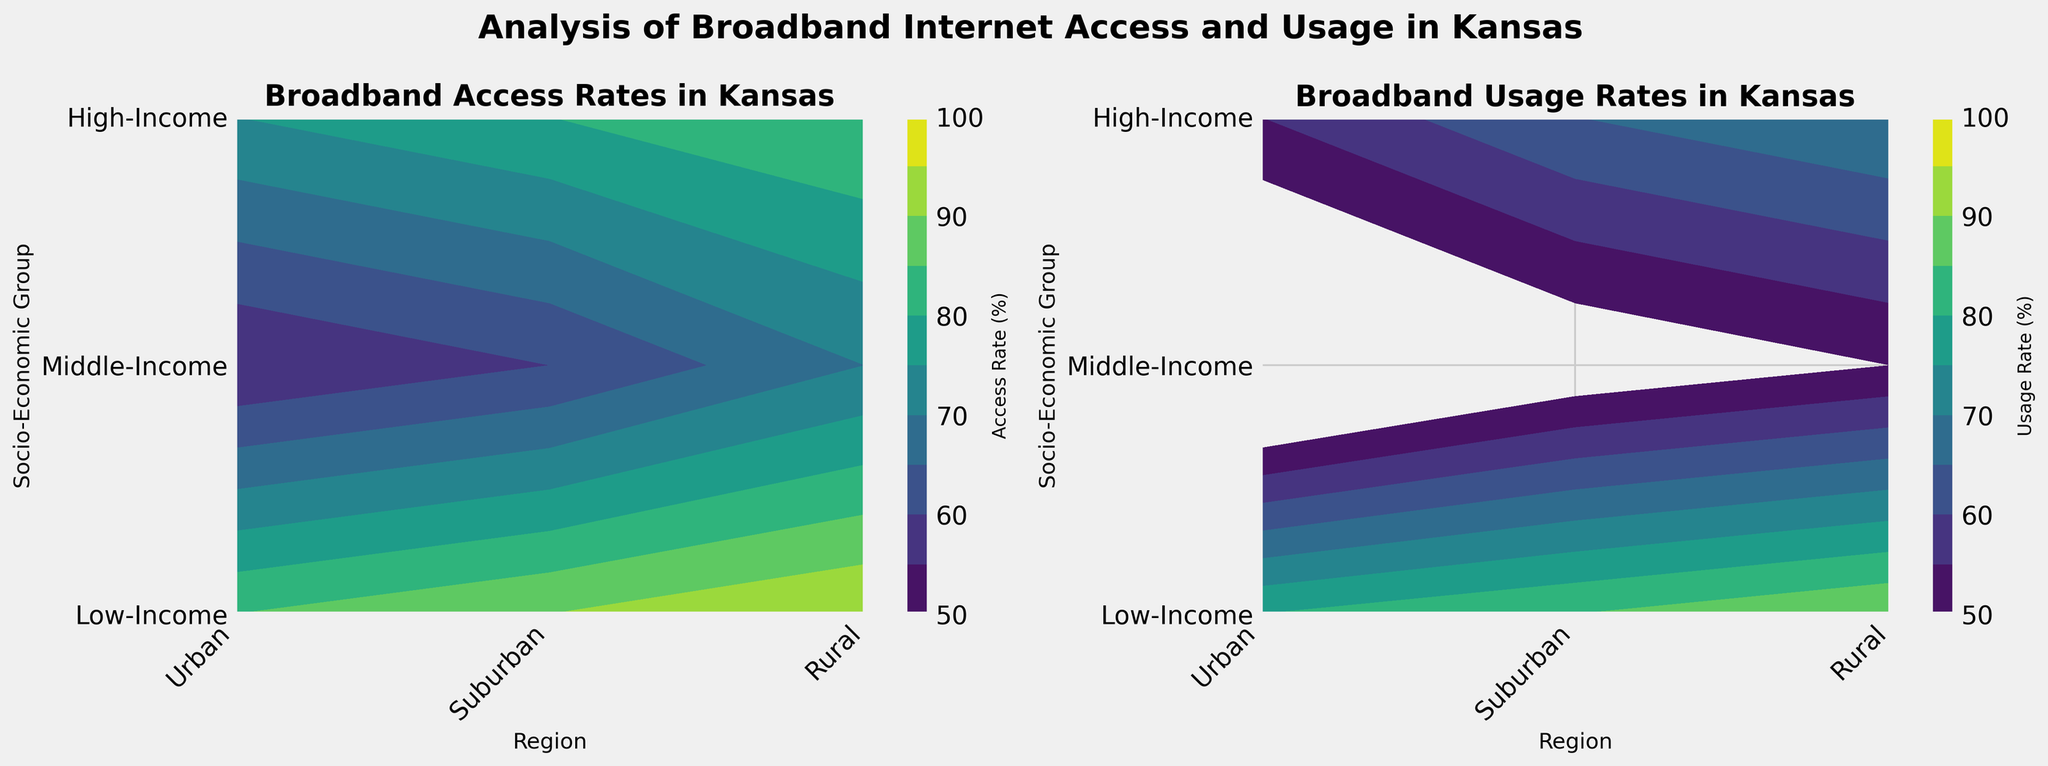What is the highest broadband access rate among all socio-economic groups and regions? To find the highest broadband access rate, look at the color gradients on the "Broadband Access Rates in Kansas" contour plot. The darkest color will represent the highest rate. Cross-reference this color with the socio-economic group and region.
Answer: 95% Which socio-economic group has the lowest broadband usage rate in rural areas? Examine the "Broadband Usage Rates in Kansas" contour plot, focusing on the rural areas (last column). Identify the socio-economic group corresponding to the lightest color (indicating the lowest value).
Answer: Low-Income How does the broadband usage rate in suburban areas for middle-income groups compare to low-income groups? Look at the "Broadband Usage Rates in Kansas" contour plot. Compare the shades of color in the suburban region (middle column) for both the middle-income and low-income groups (y-axis labels). Middle-income has a darker shade compared to low-income, indicating a higher usage rate.
Answer: Higher What is the average broadband access rate for the high-income group across all regions? Identify the access rates for the high-income group in urban, suburban, and rural regions: 95% (Urban), 90% (Suburban), and 85% (Rural). Add these rates and divide by the number of regions (3). (95 + 90 + 85) / 3 = 270 / 3.
Answer: 90% Which region experiences the most significant difference between broadband access and usage rates for middle-income groups? Find the difference between broadband access and usage rates for middle-income groups in each region: Urban (85 - 70), Suburban (80 - 65), Rural (75 - 55). Compare these differences. Urban: 15, Suburban: 15, Rural: 20. The rural region has the most significant difference.
Answer: Rural Is the broadband access rate generally higher or lower than the usage rate for all socio-economic groups? Compare color gradients in both plots. Generally, the access rates (contour plot to the left) have darker shades compared to the usage rates (contour plot to the right), indicating higher access rates relative to usage rates.
Answer: Higher What's the range of broadband usage rates for the low-income group across all regions? Look at the "Broadband Usage Rates in Kansas" contour plot. Identify the usage rates for the low-income group across Urban, Suburban, and Rural regions: 50%, 45%, and 35% respectively. The range is calculated by subtracting the minimum value from the maximum value (50 - 35).
Answer: 15% Which region shows the least variance in broadband access rates across all socio-economic groups? Identify the access rates in each region: Urban (70, 85, 95), Suburban (60, 80, 90), Rural (55, 75, 85). Calculate the range for each region and compare: Urban (95-70=25), Suburban (90-60=30), Rural (85-55=30). The Urban region shows the least variance of 25.
Answer: Urban 